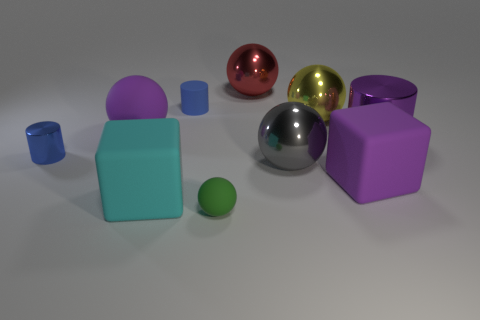Subtract all cylinders. How many objects are left? 7 Subtract 2 balls. How many balls are left? 3 Add 5 big blue rubber balls. How many big blue rubber balls exist? 5 Subtract all purple balls. How many balls are left? 4 Subtract all metal cylinders. How many cylinders are left? 1 Subtract 0 brown balls. How many objects are left? 10 Subtract all blue spheres. Subtract all cyan cylinders. How many spheres are left? 5 Subtract all brown cylinders. How many yellow blocks are left? 0 Subtract all big cyan metal things. Subtract all large purple balls. How many objects are left? 9 Add 3 yellow things. How many yellow things are left? 4 